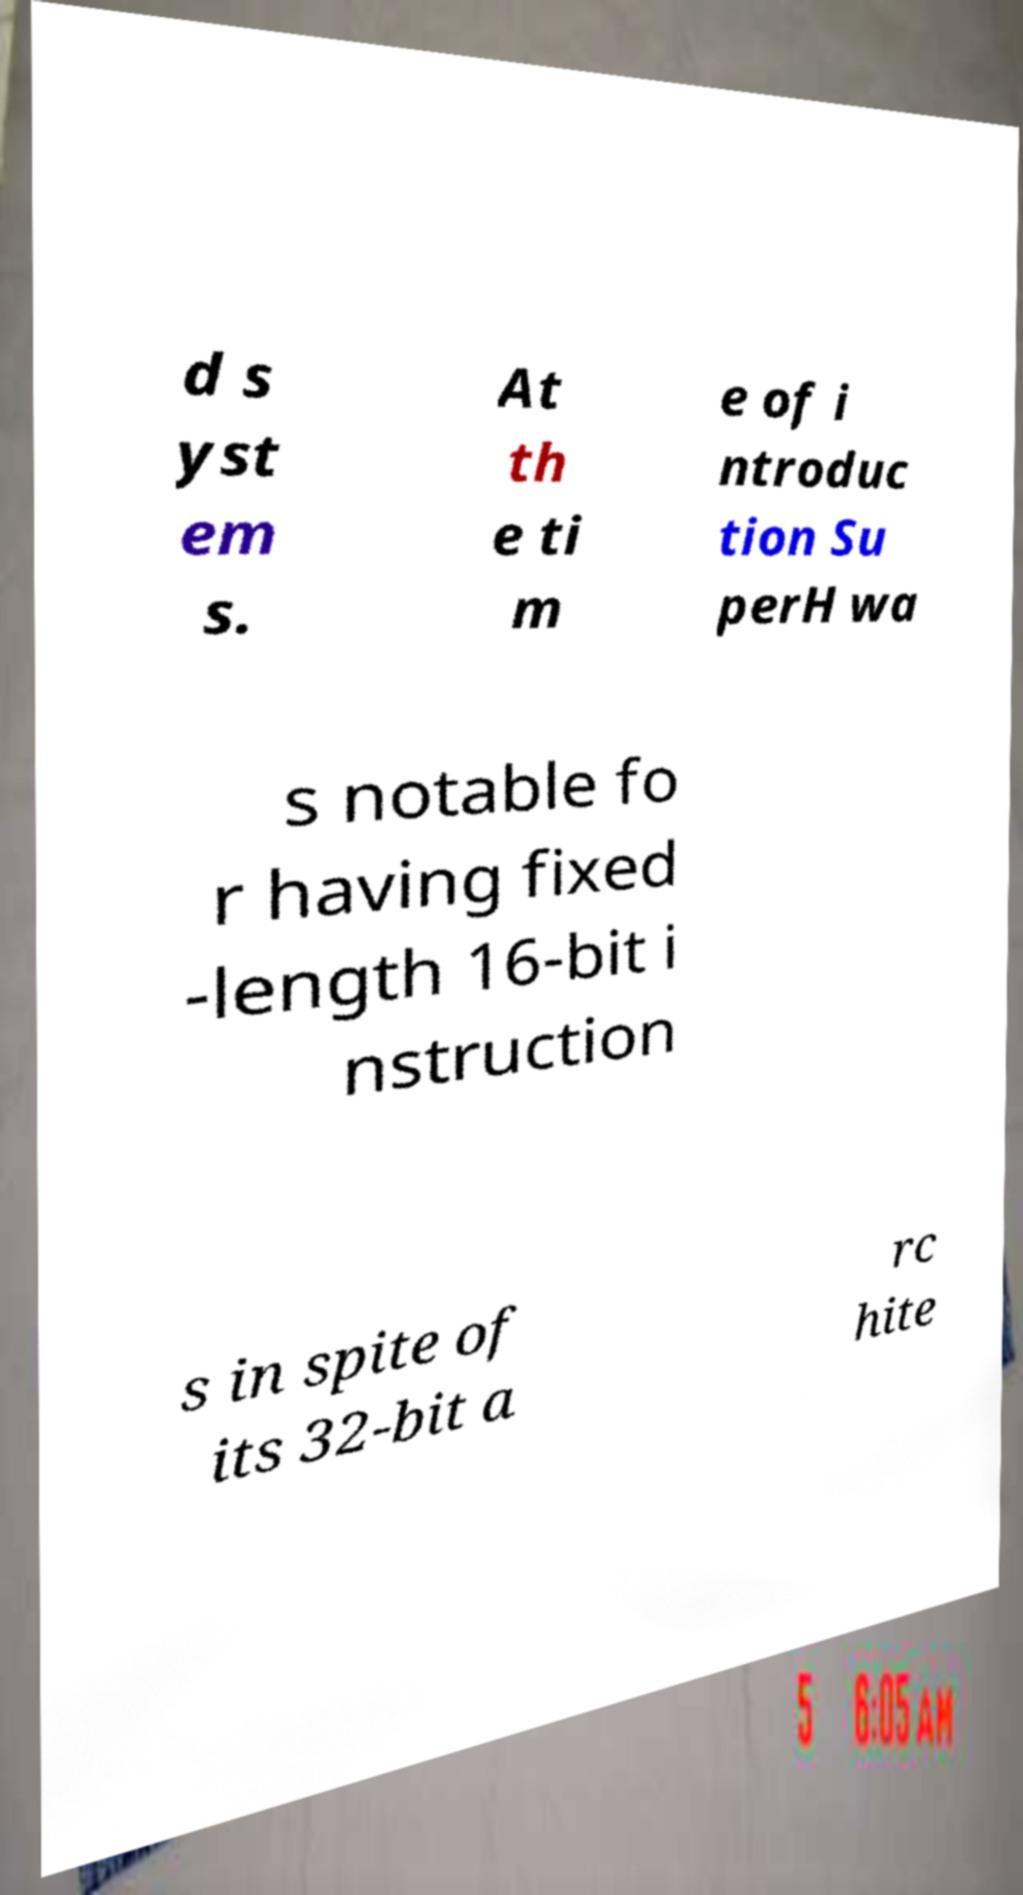Can you accurately transcribe the text from the provided image for me? d s yst em s. At th e ti m e of i ntroduc tion Su perH wa s notable fo r having fixed -length 16-bit i nstruction s in spite of its 32-bit a rc hite 